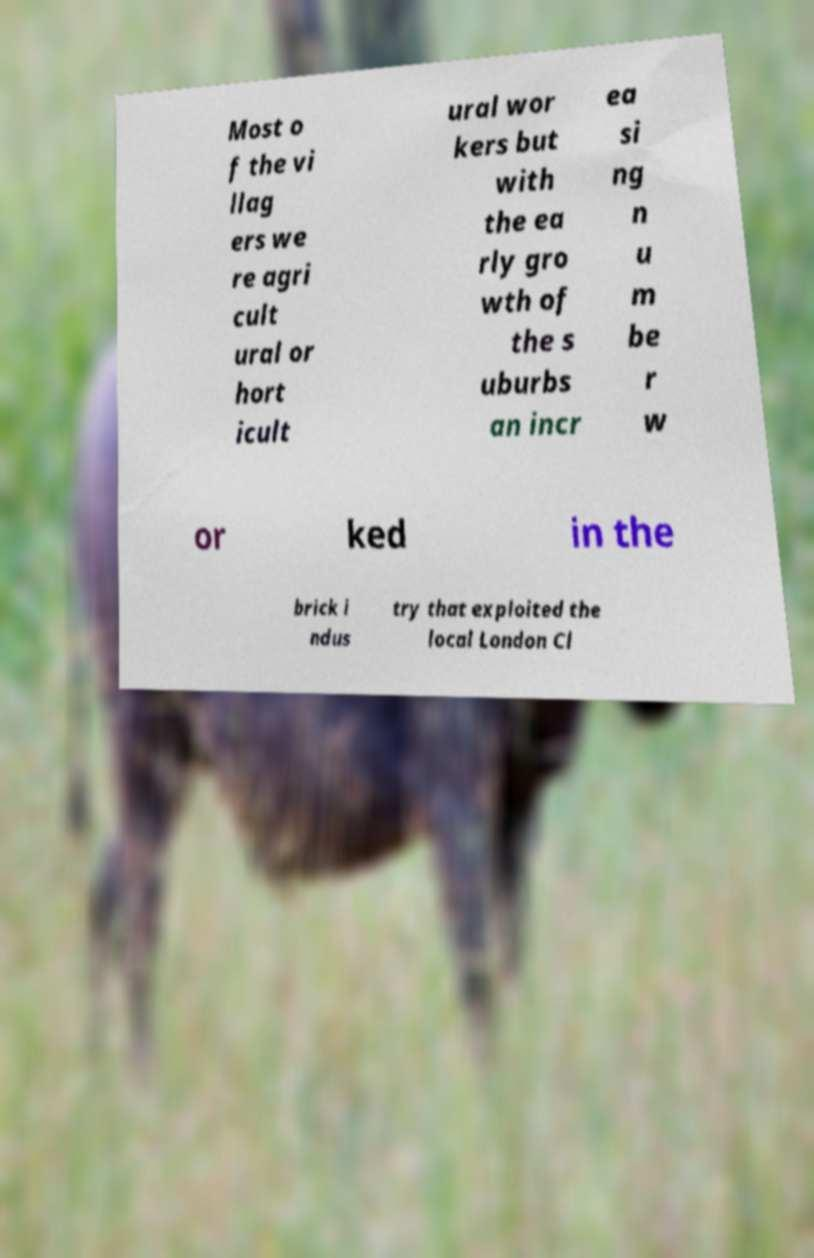Can you accurately transcribe the text from the provided image for me? Most o f the vi llag ers we re agri cult ural or hort icult ural wor kers but with the ea rly gro wth of the s uburbs an incr ea si ng n u m be r w or ked in the brick i ndus try that exploited the local London Cl 